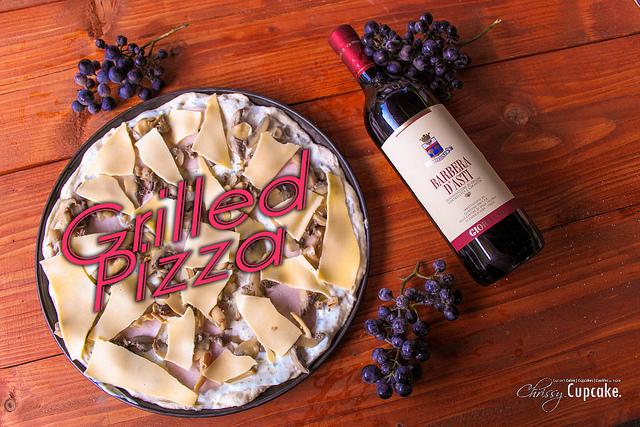What kind of fruits are on the table?
Quick response, please. Grapes. Is the pizza hot?
Give a very brief answer. No. What is in the bottle?
Quick response, please. Wine. 